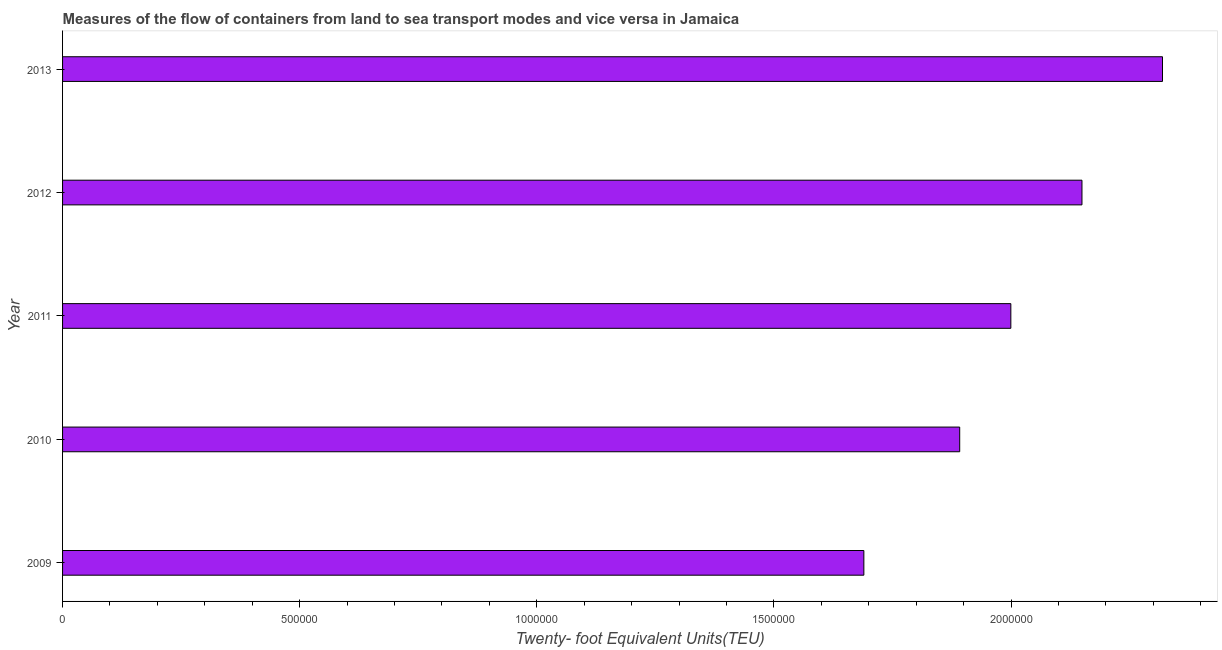Does the graph contain any zero values?
Provide a short and direct response. No. Does the graph contain grids?
Your answer should be compact. No. What is the title of the graph?
Provide a succinct answer. Measures of the flow of containers from land to sea transport modes and vice versa in Jamaica. What is the label or title of the X-axis?
Ensure brevity in your answer.  Twenty- foot Equivalent Units(TEU). What is the container port traffic in 2010?
Provide a succinct answer. 1.89e+06. Across all years, what is the maximum container port traffic?
Your answer should be compact. 2.32e+06. Across all years, what is the minimum container port traffic?
Ensure brevity in your answer.  1.69e+06. In which year was the container port traffic maximum?
Ensure brevity in your answer.  2013. What is the sum of the container port traffic?
Your answer should be very brief. 1.00e+07. What is the difference between the container port traffic in 2010 and 2011?
Make the answer very short. -1.08e+05. What is the average container port traffic per year?
Offer a terse response. 2.01e+06. What is the median container port traffic?
Your response must be concise. 2.00e+06. In how many years, is the container port traffic greater than 1100000 TEU?
Ensure brevity in your answer.  5. Do a majority of the years between 2009 and 2011 (inclusive) have container port traffic greater than 1900000 TEU?
Make the answer very short. No. What is the ratio of the container port traffic in 2010 to that in 2011?
Give a very brief answer. 0.95. Is the difference between the container port traffic in 2011 and 2012 greater than the difference between any two years?
Offer a terse response. No. What is the difference between the highest and the second highest container port traffic?
Make the answer very short. 1.70e+05. Is the sum of the container port traffic in 2009 and 2013 greater than the maximum container port traffic across all years?
Your response must be concise. Yes. What is the difference between the highest and the lowest container port traffic?
Offer a very short reply. 6.30e+05. How many bars are there?
Ensure brevity in your answer.  5. How many years are there in the graph?
Provide a short and direct response. 5. What is the Twenty- foot Equivalent Units(TEU) of 2009?
Offer a very short reply. 1.69e+06. What is the Twenty- foot Equivalent Units(TEU) in 2010?
Provide a succinct answer. 1.89e+06. What is the Twenty- foot Equivalent Units(TEU) of 2011?
Provide a succinct answer. 2.00e+06. What is the Twenty- foot Equivalent Units(TEU) in 2012?
Give a very brief answer. 2.15e+06. What is the Twenty- foot Equivalent Units(TEU) of 2013?
Offer a terse response. 2.32e+06. What is the difference between the Twenty- foot Equivalent Units(TEU) in 2009 and 2010?
Your response must be concise. -2.02e+05. What is the difference between the Twenty- foot Equivalent Units(TEU) in 2009 and 2011?
Your response must be concise. -3.10e+05. What is the difference between the Twenty- foot Equivalent Units(TEU) in 2009 and 2012?
Offer a very short reply. -4.60e+05. What is the difference between the Twenty- foot Equivalent Units(TEU) in 2009 and 2013?
Keep it short and to the point. -6.30e+05. What is the difference between the Twenty- foot Equivalent Units(TEU) in 2010 and 2011?
Provide a short and direct response. -1.08e+05. What is the difference between the Twenty- foot Equivalent Units(TEU) in 2010 and 2012?
Your answer should be compact. -2.58e+05. What is the difference between the Twenty- foot Equivalent Units(TEU) in 2010 and 2013?
Your answer should be compact. -4.28e+05. What is the difference between the Twenty- foot Equivalent Units(TEU) in 2011 and 2012?
Your response must be concise. -1.50e+05. What is the difference between the Twenty- foot Equivalent Units(TEU) in 2011 and 2013?
Provide a succinct answer. -3.20e+05. What is the difference between the Twenty- foot Equivalent Units(TEU) in 2012 and 2013?
Your answer should be compact. -1.70e+05. What is the ratio of the Twenty- foot Equivalent Units(TEU) in 2009 to that in 2010?
Your answer should be very brief. 0.89. What is the ratio of the Twenty- foot Equivalent Units(TEU) in 2009 to that in 2011?
Your answer should be compact. 0.84. What is the ratio of the Twenty- foot Equivalent Units(TEU) in 2009 to that in 2012?
Provide a succinct answer. 0.79. What is the ratio of the Twenty- foot Equivalent Units(TEU) in 2009 to that in 2013?
Your response must be concise. 0.73. What is the ratio of the Twenty- foot Equivalent Units(TEU) in 2010 to that in 2011?
Your answer should be very brief. 0.95. What is the ratio of the Twenty- foot Equivalent Units(TEU) in 2010 to that in 2012?
Ensure brevity in your answer.  0.88. What is the ratio of the Twenty- foot Equivalent Units(TEU) in 2010 to that in 2013?
Offer a very short reply. 0.82. What is the ratio of the Twenty- foot Equivalent Units(TEU) in 2011 to that in 2013?
Your answer should be very brief. 0.86. What is the ratio of the Twenty- foot Equivalent Units(TEU) in 2012 to that in 2013?
Your answer should be very brief. 0.93. 